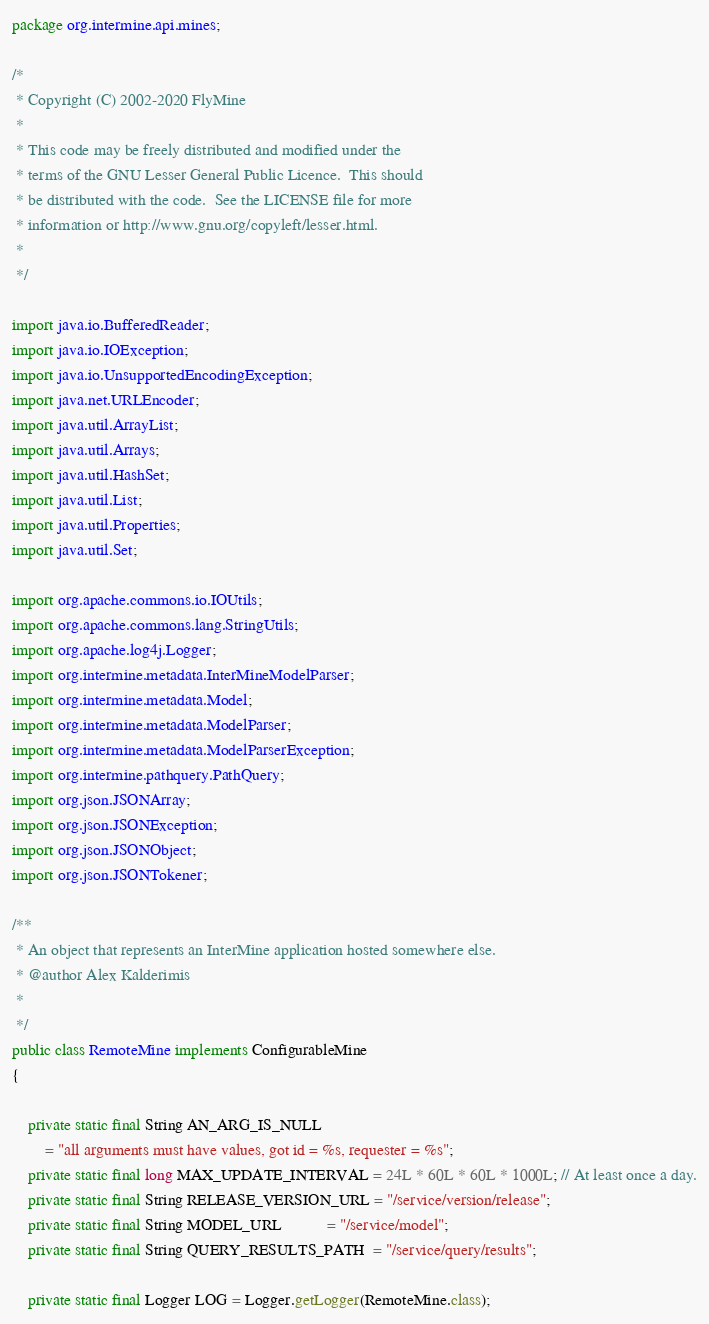Convert code to text. <code><loc_0><loc_0><loc_500><loc_500><_Java_>package org.intermine.api.mines;

/*
 * Copyright (C) 2002-2020 FlyMine
 *
 * This code may be freely distributed and modified under the
 * terms of the GNU Lesser General Public Licence.  This should
 * be distributed with the code.  See the LICENSE file for more
 * information or http://www.gnu.org/copyleft/lesser.html.
 *
 */

import java.io.BufferedReader;
import java.io.IOException;
import java.io.UnsupportedEncodingException;
import java.net.URLEncoder;
import java.util.ArrayList;
import java.util.Arrays;
import java.util.HashSet;
import java.util.List;
import java.util.Properties;
import java.util.Set;

import org.apache.commons.io.IOUtils;
import org.apache.commons.lang.StringUtils;
import org.apache.log4j.Logger;
import org.intermine.metadata.InterMineModelParser;
import org.intermine.metadata.Model;
import org.intermine.metadata.ModelParser;
import org.intermine.metadata.ModelParserException;
import org.intermine.pathquery.PathQuery;
import org.json.JSONArray;
import org.json.JSONException;
import org.json.JSONObject;
import org.json.JSONTokener;

/**
 * An object that represents an InterMine application hosted somewhere else.
 * @author Alex Kalderimis
 *
 */
public class RemoteMine implements ConfigurableMine
{

    private static final String AN_ARG_IS_NULL
        = "all arguments must have values, got id = %s, requester = %s";
    private static final long MAX_UPDATE_INTERVAL = 24L * 60L * 60L * 1000L; // At least once a day.
    private static final String RELEASE_VERSION_URL = "/service/version/release";
    private static final String MODEL_URL           = "/service/model";
    private static final String QUERY_RESULTS_PATH  = "/service/query/results";

    private static final Logger LOG = Logger.getLogger(RemoteMine.class);
</code> 